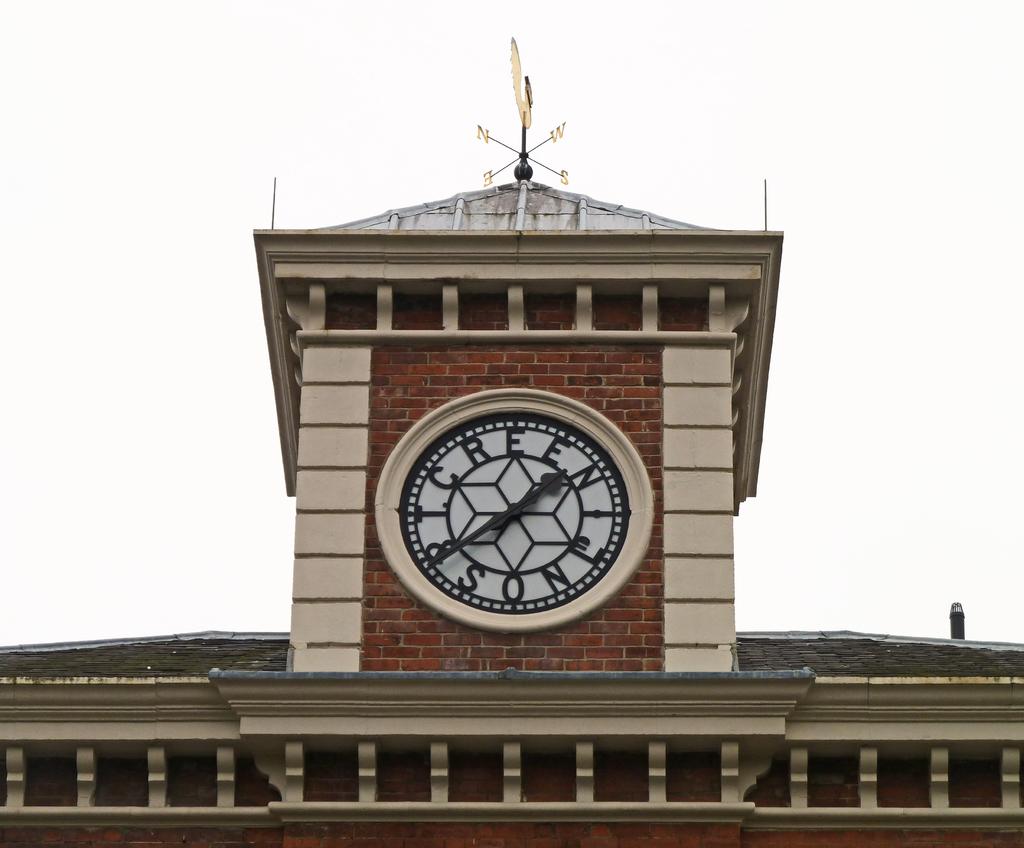What time is it?
Provide a succinct answer. 1:40. What is written around the clock?
Your answer should be compact. T. creen and son. 